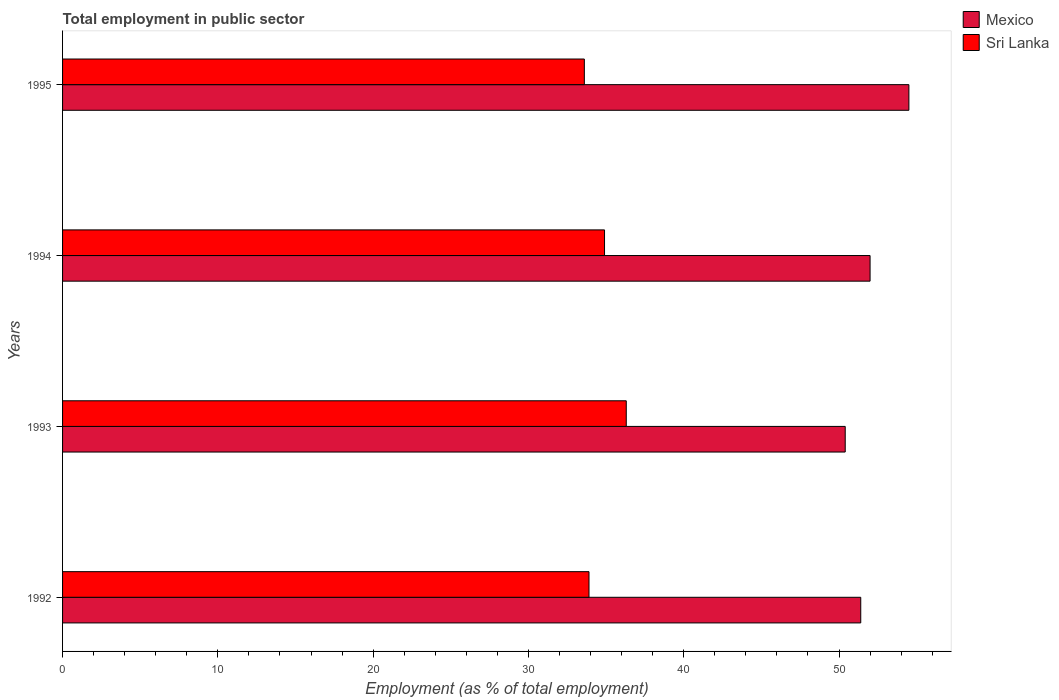How many groups of bars are there?
Your answer should be compact. 4. Are the number of bars per tick equal to the number of legend labels?
Offer a very short reply. Yes. What is the label of the 2nd group of bars from the top?
Provide a short and direct response. 1994. In how many cases, is the number of bars for a given year not equal to the number of legend labels?
Provide a succinct answer. 0. What is the employment in public sector in Sri Lanka in 1993?
Make the answer very short. 36.3. Across all years, what is the maximum employment in public sector in Sri Lanka?
Your answer should be very brief. 36.3. Across all years, what is the minimum employment in public sector in Mexico?
Make the answer very short. 50.4. In which year was the employment in public sector in Sri Lanka maximum?
Give a very brief answer. 1993. In which year was the employment in public sector in Sri Lanka minimum?
Ensure brevity in your answer.  1995. What is the total employment in public sector in Mexico in the graph?
Make the answer very short. 208.3. What is the difference between the employment in public sector in Mexico in 1992 and that in 1993?
Keep it short and to the point. 1. What is the difference between the employment in public sector in Sri Lanka in 1994 and the employment in public sector in Mexico in 1995?
Keep it short and to the point. -19.6. What is the average employment in public sector in Mexico per year?
Make the answer very short. 52.08. In the year 1995, what is the difference between the employment in public sector in Mexico and employment in public sector in Sri Lanka?
Your answer should be compact. 20.9. What is the ratio of the employment in public sector in Mexico in 1994 to that in 1995?
Provide a short and direct response. 0.95. Is the difference between the employment in public sector in Mexico in 1992 and 1993 greater than the difference between the employment in public sector in Sri Lanka in 1992 and 1993?
Keep it short and to the point. Yes. What is the difference between the highest and the second highest employment in public sector in Sri Lanka?
Your answer should be compact. 1.4. What is the difference between the highest and the lowest employment in public sector in Sri Lanka?
Give a very brief answer. 2.7. In how many years, is the employment in public sector in Sri Lanka greater than the average employment in public sector in Sri Lanka taken over all years?
Offer a very short reply. 2. Is the sum of the employment in public sector in Mexico in 1993 and 1995 greater than the maximum employment in public sector in Sri Lanka across all years?
Offer a terse response. Yes. What does the 2nd bar from the bottom in 1995 represents?
Your answer should be compact. Sri Lanka. How many bars are there?
Your answer should be compact. 8. What is the difference between two consecutive major ticks on the X-axis?
Keep it short and to the point. 10. Does the graph contain grids?
Your answer should be very brief. No. Where does the legend appear in the graph?
Provide a succinct answer. Top right. How are the legend labels stacked?
Provide a succinct answer. Vertical. What is the title of the graph?
Offer a terse response. Total employment in public sector. What is the label or title of the X-axis?
Provide a short and direct response. Employment (as % of total employment). What is the Employment (as % of total employment) in Mexico in 1992?
Make the answer very short. 51.4. What is the Employment (as % of total employment) in Sri Lanka in 1992?
Your response must be concise. 33.9. What is the Employment (as % of total employment) in Mexico in 1993?
Offer a terse response. 50.4. What is the Employment (as % of total employment) of Sri Lanka in 1993?
Your response must be concise. 36.3. What is the Employment (as % of total employment) in Sri Lanka in 1994?
Your answer should be compact. 34.9. What is the Employment (as % of total employment) of Mexico in 1995?
Ensure brevity in your answer.  54.5. What is the Employment (as % of total employment) of Sri Lanka in 1995?
Ensure brevity in your answer.  33.6. Across all years, what is the maximum Employment (as % of total employment) in Mexico?
Keep it short and to the point. 54.5. Across all years, what is the maximum Employment (as % of total employment) in Sri Lanka?
Ensure brevity in your answer.  36.3. Across all years, what is the minimum Employment (as % of total employment) in Mexico?
Your answer should be very brief. 50.4. Across all years, what is the minimum Employment (as % of total employment) of Sri Lanka?
Give a very brief answer. 33.6. What is the total Employment (as % of total employment) of Mexico in the graph?
Offer a very short reply. 208.3. What is the total Employment (as % of total employment) in Sri Lanka in the graph?
Offer a very short reply. 138.7. What is the difference between the Employment (as % of total employment) in Mexico in 1992 and that in 1993?
Your answer should be compact. 1. What is the difference between the Employment (as % of total employment) in Sri Lanka in 1992 and that in 1993?
Offer a terse response. -2.4. What is the difference between the Employment (as % of total employment) in Sri Lanka in 1992 and that in 1994?
Your response must be concise. -1. What is the difference between the Employment (as % of total employment) of Mexico in 1992 and that in 1995?
Provide a succinct answer. -3.1. What is the difference between the Employment (as % of total employment) in Sri Lanka in 1993 and that in 1994?
Keep it short and to the point. 1.4. What is the difference between the Employment (as % of total employment) in Mexico in 1993 and that in 1995?
Make the answer very short. -4.1. What is the difference between the Employment (as % of total employment) in Sri Lanka in 1993 and that in 1995?
Keep it short and to the point. 2.7. What is the difference between the Employment (as % of total employment) of Mexico in 1994 and that in 1995?
Offer a terse response. -2.5. What is the difference between the Employment (as % of total employment) of Mexico in 1992 and the Employment (as % of total employment) of Sri Lanka in 1993?
Ensure brevity in your answer.  15.1. What is the difference between the Employment (as % of total employment) in Mexico in 1992 and the Employment (as % of total employment) in Sri Lanka in 1994?
Ensure brevity in your answer.  16.5. What is the difference between the Employment (as % of total employment) of Mexico in 1992 and the Employment (as % of total employment) of Sri Lanka in 1995?
Ensure brevity in your answer.  17.8. What is the difference between the Employment (as % of total employment) in Mexico in 1994 and the Employment (as % of total employment) in Sri Lanka in 1995?
Ensure brevity in your answer.  18.4. What is the average Employment (as % of total employment) in Mexico per year?
Your response must be concise. 52.08. What is the average Employment (as % of total employment) of Sri Lanka per year?
Give a very brief answer. 34.67. In the year 1992, what is the difference between the Employment (as % of total employment) of Mexico and Employment (as % of total employment) of Sri Lanka?
Your answer should be very brief. 17.5. In the year 1993, what is the difference between the Employment (as % of total employment) of Mexico and Employment (as % of total employment) of Sri Lanka?
Your answer should be compact. 14.1. In the year 1994, what is the difference between the Employment (as % of total employment) of Mexico and Employment (as % of total employment) of Sri Lanka?
Make the answer very short. 17.1. In the year 1995, what is the difference between the Employment (as % of total employment) in Mexico and Employment (as % of total employment) in Sri Lanka?
Make the answer very short. 20.9. What is the ratio of the Employment (as % of total employment) of Mexico in 1992 to that in 1993?
Offer a terse response. 1.02. What is the ratio of the Employment (as % of total employment) of Sri Lanka in 1992 to that in 1993?
Your answer should be compact. 0.93. What is the ratio of the Employment (as % of total employment) in Sri Lanka in 1992 to that in 1994?
Offer a terse response. 0.97. What is the ratio of the Employment (as % of total employment) in Mexico in 1992 to that in 1995?
Make the answer very short. 0.94. What is the ratio of the Employment (as % of total employment) of Sri Lanka in 1992 to that in 1995?
Offer a very short reply. 1.01. What is the ratio of the Employment (as % of total employment) of Mexico in 1993 to that in 1994?
Keep it short and to the point. 0.97. What is the ratio of the Employment (as % of total employment) of Sri Lanka in 1993 to that in 1994?
Make the answer very short. 1.04. What is the ratio of the Employment (as % of total employment) in Mexico in 1993 to that in 1995?
Give a very brief answer. 0.92. What is the ratio of the Employment (as % of total employment) of Sri Lanka in 1993 to that in 1995?
Your response must be concise. 1.08. What is the ratio of the Employment (as % of total employment) of Mexico in 1994 to that in 1995?
Provide a succinct answer. 0.95. What is the ratio of the Employment (as % of total employment) in Sri Lanka in 1994 to that in 1995?
Give a very brief answer. 1.04. What is the difference between the highest and the second highest Employment (as % of total employment) in Sri Lanka?
Give a very brief answer. 1.4. What is the difference between the highest and the lowest Employment (as % of total employment) in Mexico?
Give a very brief answer. 4.1. 